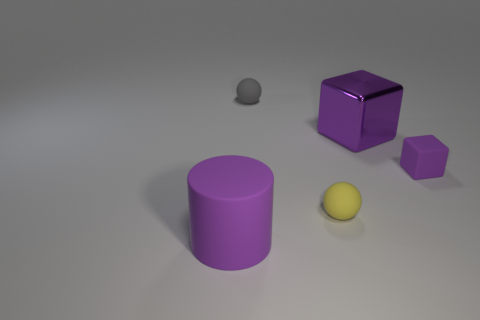Is there any other thing that is the same size as the matte cylinder?
Provide a short and direct response. Yes. There is a small matte object that is the same color as the metal object; what shape is it?
Make the answer very short. Cube. Is there anything else that has the same shape as the big purple rubber thing?
Offer a very short reply. No. What is the material of the object that is on the right side of the small yellow rubber sphere and behind the small purple matte cube?
Offer a very short reply. Metal. What shape is the large purple thing on the left side of the tiny sphere behind the yellow matte ball?
Offer a terse response. Cylinder. Is the color of the large metal thing the same as the large rubber cylinder?
Offer a terse response. Yes. How many gray objects are tiny rubber objects or small matte cubes?
Ensure brevity in your answer.  1. There is a metallic cube; are there any purple matte objects on the right side of it?
Your answer should be very brief. Yes. How big is the purple metallic cube?
Your answer should be very brief. Large. There is another object that is the same shape as the tiny purple thing; what is its size?
Give a very brief answer. Large. 